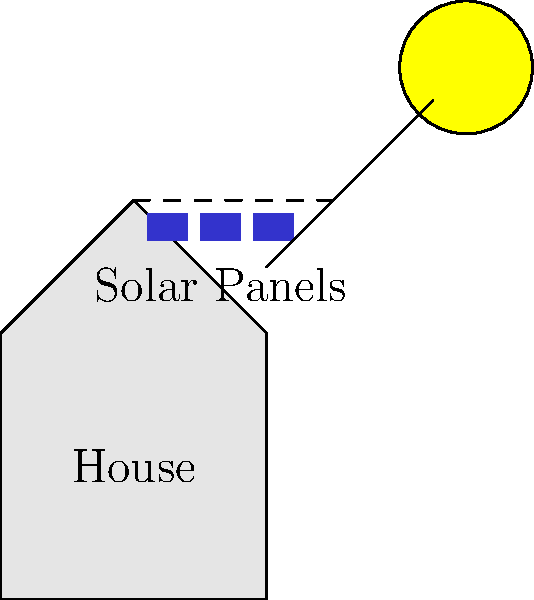Your neighbor is considering installing solar panels on their roof to reduce energy costs. If the average daily sunlight in your area is 5 hours, and each solar panel can produce 250 watts of power, how many kilowatt-hours (kWh) of energy can be generated by a system of 10 panels over a 30-day month? To solve this problem, let's break it down into steps:

1. Calculate the total power output of the solar panel system:
   - Each panel produces 250 watts
   - There are 10 panels
   - Total power = $250 \text{ W} \times 10 = 2500 \text{ W} = 2.5 \text{ kW}$

2. Determine the daily energy production:
   - The system produces 2.5 kW for 5 hours per day
   - Daily energy = $2.5 \text{ kW} \times 5 \text{ hours} = 12.5 \text{ kWh}$

3. Calculate the monthly energy production:
   - There are 30 days in the given month
   - Monthly energy = $12.5 \text{ kWh} \times 30 \text{ days} = 375 \text{ kWh}$

Therefore, the 10-panel solar system can generate 375 kWh of energy over a 30-day month.
Answer: 375 kWh 